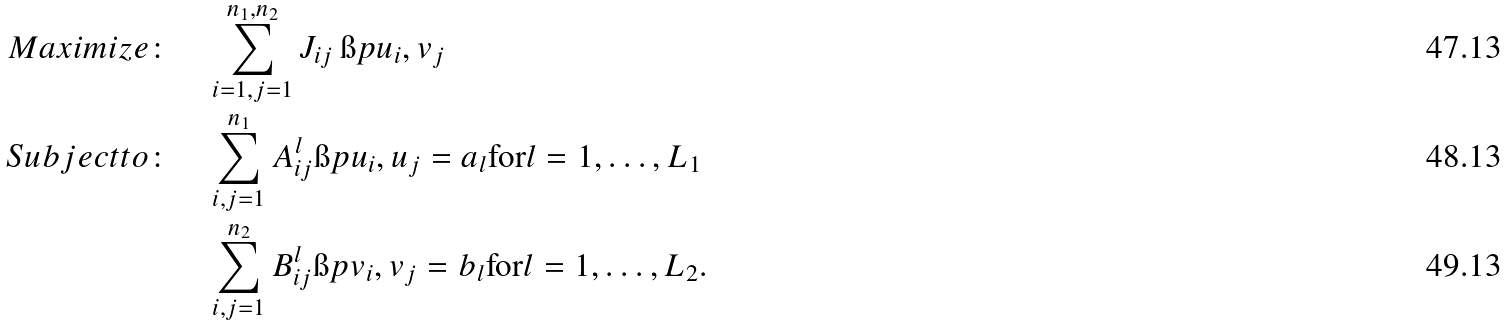<formula> <loc_0><loc_0><loc_500><loc_500>M a x i m i z e \colon \quad & \sum _ { i = 1 , j = 1 } ^ { n _ { 1 } , n _ { 2 } } J _ { i j } \, \i p { u _ { i } , v _ { j } } \\ S u b j e c t t o \colon \quad & \sum _ { i , j = 1 } ^ { n _ { 1 } } A ^ { l } _ { i j } \i p { u _ { i } , u _ { j } } = a _ { l } \text {for} l = 1 , \dots , L _ { 1 } \\ & \sum _ { i , j = 1 } ^ { n _ { 2 } } B ^ { l } _ { i j } \i p { v _ { i } , v _ { j } } = b _ { l } \text {for} l = 1 , \dots , L _ { 2 } .</formula> 